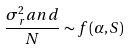Convert formula to latex. <formula><loc_0><loc_0><loc_500><loc_500>\frac { \sigma ^ { 2 } _ { r } a n d } { N } \sim f ( \alpha , S )</formula> 